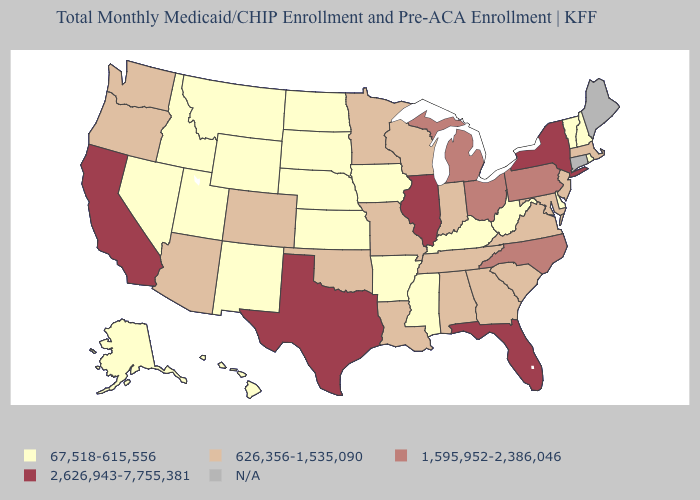Does California have the highest value in the USA?
Short answer required. Yes. What is the lowest value in the USA?
Write a very short answer. 67,518-615,556. What is the value of Florida?
Quick response, please. 2,626,943-7,755,381. Name the states that have a value in the range 67,518-615,556?
Concise answer only. Alaska, Arkansas, Delaware, Hawaii, Idaho, Iowa, Kansas, Kentucky, Mississippi, Montana, Nebraska, Nevada, New Hampshire, New Mexico, North Dakota, Rhode Island, South Dakota, Utah, Vermont, West Virginia, Wyoming. Which states have the lowest value in the South?
Write a very short answer. Arkansas, Delaware, Kentucky, Mississippi, West Virginia. What is the highest value in the USA?
Concise answer only. 2,626,943-7,755,381. Does the first symbol in the legend represent the smallest category?
Quick response, please. Yes. What is the value of Wisconsin?
Be succinct. 626,356-1,535,090. Is the legend a continuous bar?
Short answer required. No. Name the states that have a value in the range 67,518-615,556?
Give a very brief answer. Alaska, Arkansas, Delaware, Hawaii, Idaho, Iowa, Kansas, Kentucky, Mississippi, Montana, Nebraska, Nevada, New Hampshire, New Mexico, North Dakota, Rhode Island, South Dakota, Utah, Vermont, West Virginia, Wyoming. Which states have the lowest value in the USA?
Write a very short answer. Alaska, Arkansas, Delaware, Hawaii, Idaho, Iowa, Kansas, Kentucky, Mississippi, Montana, Nebraska, Nevada, New Hampshire, New Mexico, North Dakota, Rhode Island, South Dakota, Utah, Vermont, West Virginia, Wyoming. What is the value of Rhode Island?
Short answer required. 67,518-615,556. Name the states that have a value in the range 67,518-615,556?
Keep it brief. Alaska, Arkansas, Delaware, Hawaii, Idaho, Iowa, Kansas, Kentucky, Mississippi, Montana, Nebraska, Nevada, New Hampshire, New Mexico, North Dakota, Rhode Island, South Dakota, Utah, Vermont, West Virginia, Wyoming. 